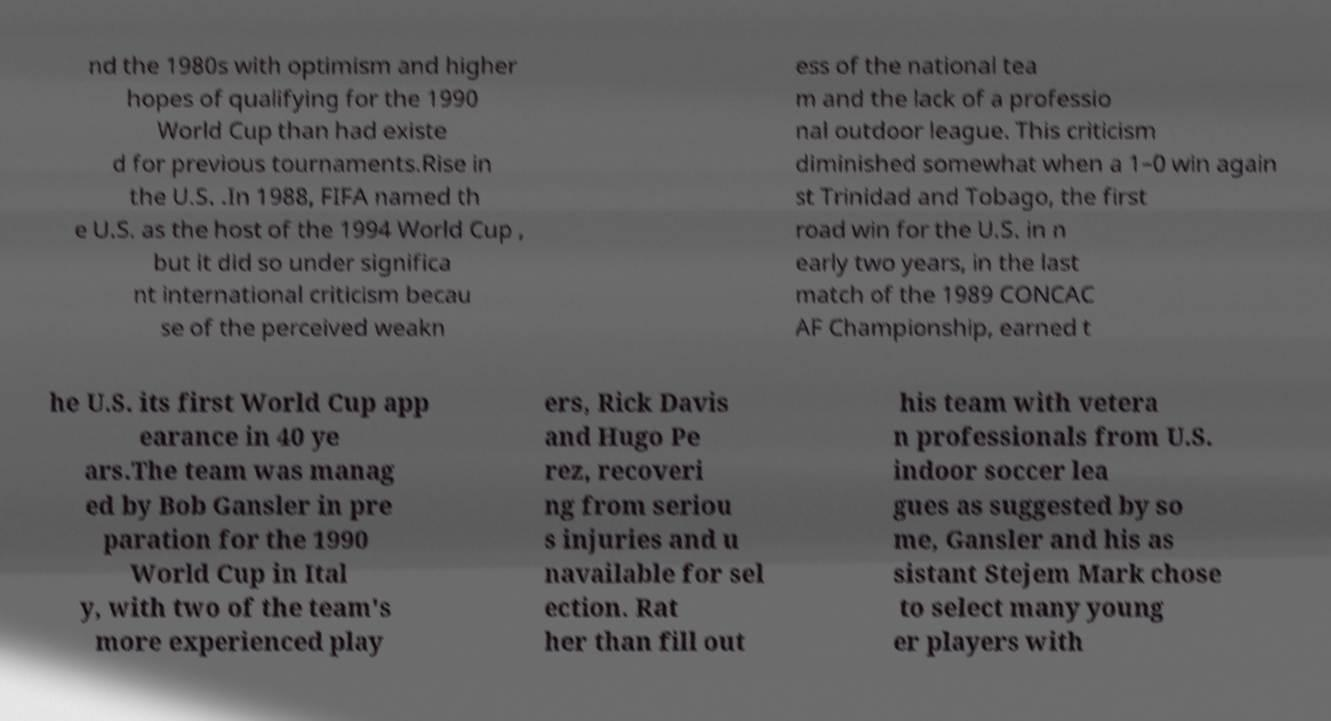There's text embedded in this image that I need extracted. Can you transcribe it verbatim? nd the 1980s with optimism and higher hopes of qualifying for the 1990 World Cup than had existe d for previous tournaments.Rise in the U.S. .In 1988, FIFA named th e U.S. as the host of the 1994 World Cup , but it did so under significa nt international criticism becau se of the perceived weakn ess of the national tea m and the lack of a professio nal outdoor league. This criticism diminished somewhat when a 1–0 win again st Trinidad and Tobago, the first road win for the U.S. in n early two years, in the last match of the 1989 CONCAC AF Championship, earned t he U.S. its first World Cup app earance in 40 ye ars.The team was manag ed by Bob Gansler in pre paration for the 1990 World Cup in Ital y, with two of the team's more experienced play ers, Rick Davis and Hugo Pe rez, recoveri ng from seriou s injuries and u navailable for sel ection. Rat her than fill out his team with vetera n professionals from U.S. indoor soccer lea gues as suggested by so me, Gansler and his as sistant Stejem Mark chose to select many young er players with 